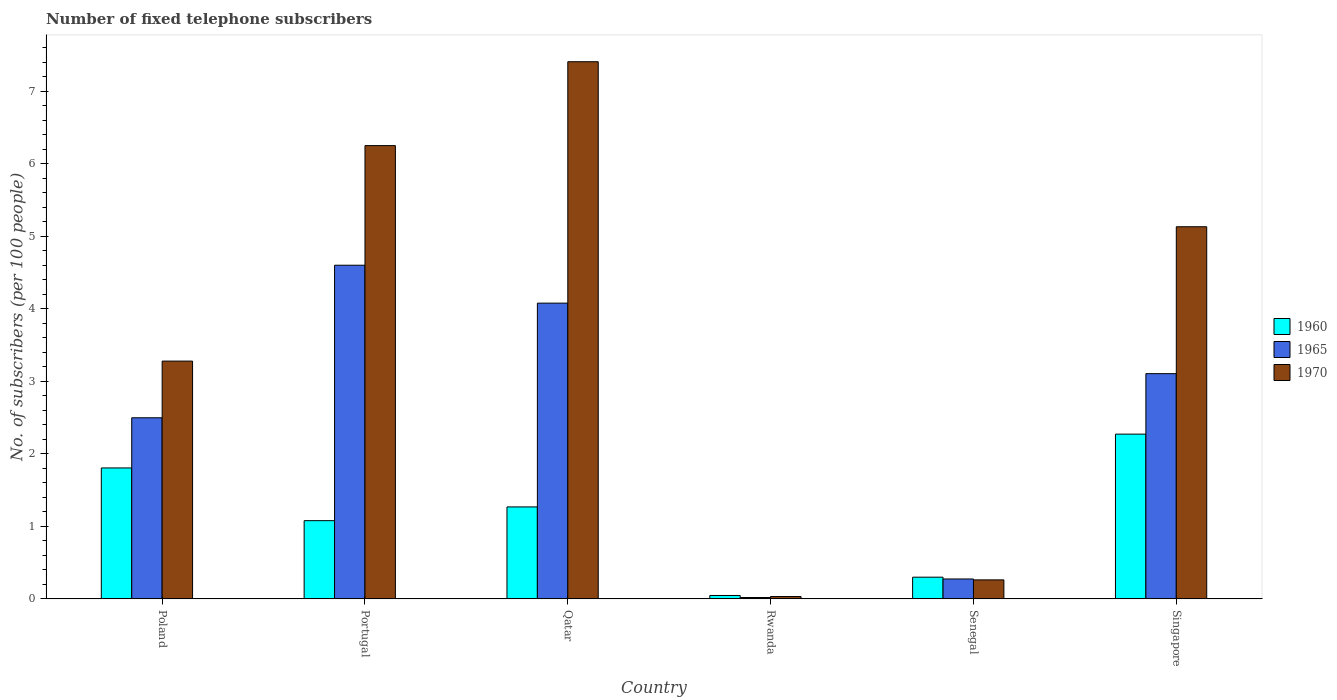What is the label of the 3rd group of bars from the left?
Provide a short and direct response. Qatar. What is the number of fixed telephone subscribers in 1970 in Senegal?
Offer a very short reply. 0.26. Across all countries, what is the maximum number of fixed telephone subscribers in 1965?
Your response must be concise. 4.6. Across all countries, what is the minimum number of fixed telephone subscribers in 1965?
Provide a short and direct response. 0.02. In which country was the number of fixed telephone subscribers in 1970 maximum?
Ensure brevity in your answer.  Qatar. In which country was the number of fixed telephone subscribers in 1965 minimum?
Provide a succinct answer. Rwanda. What is the total number of fixed telephone subscribers in 1970 in the graph?
Keep it short and to the point. 22.36. What is the difference between the number of fixed telephone subscribers in 1970 in Portugal and that in Singapore?
Make the answer very short. 1.12. What is the difference between the number of fixed telephone subscribers in 1970 in Senegal and the number of fixed telephone subscribers in 1960 in Rwanda?
Your answer should be very brief. 0.22. What is the average number of fixed telephone subscribers in 1970 per country?
Offer a terse response. 3.73. What is the difference between the number of fixed telephone subscribers of/in 1965 and number of fixed telephone subscribers of/in 1960 in Qatar?
Your response must be concise. 2.81. What is the ratio of the number of fixed telephone subscribers in 1960 in Qatar to that in Senegal?
Provide a short and direct response. 4.24. Is the number of fixed telephone subscribers in 1970 in Portugal less than that in Rwanda?
Provide a short and direct response. No. Is the difference between the number of fixed telephone subscribers in 1965 in Poland and Rwanda greater than the difference between the number of fixed telephone subscribers in 1960 in Poland and Rwanda?
Give a very brief answer. Yes. What is the difference between the highest and the second highest number of fixed telephone subscribers in 1965?
Offer a very short reply. -1.5. What is the difference between the highest and the lowest number of fixed telephone subscribers in 1970?
Your answer should be very brief. 7.38. How many bars are there?
Keep it short and to the point. 18. How many countries are there in the graph?
Offer a very short reply. 6. Are the values on the major ticks of Y-axis written in scientific E-notation?
Give a very brief answer. No. Does the graph contain grids?
Give a very brief answer. No. How many legend labels are there?
Your response must be concise. 3. What is the title of the graph?
Offer a terse response. Number of fixed telephone subscribers. What is the label or title of the Y-axis?
Offer a very short reply. No. of subscribers (per 100 people). What is the No. of subscribers (per 100 people) in 1960 in Poland?
Your answer should be compact. 1.81. What is the No. of subscribers (per 100 people) in 1965 in Poland?
Provide a succinct answer. 2.5. What is the No. of subscribers (per 100 people) of 1970 in Poland?
Offer a terse response. 3.28. What is the No. of subscribers (per 100 people) in 1960 in Portugal?
Your response must be concise. 1.08. What is the No. of subscribers (per 100 people) of 1965 in Portugal?
Your answer should be very brief. 4.6. What is the No. of subscribers (per 100 people) of 1970 in Portugal?
Give a very brief answer. 6.25. What is the No. of subscribers (per 100 people) in 1960 in Qatar?
Offer a terse response. 1.27. What is the No. of subscribers (per 100 people) of 1965 in Qatar?
Provide a short and direct response. 4.08. What is the No. of subscribers (per 100 people) in 1970 in Qatar?
Offer a very short reply. 7.41. What is the No. of subscribers (per 100 people) of 1960 in Rwanda?
Your answer should be very brief. 0.05. What is the No. of subscribers (per 100 people) in 1965 in Rwanda?
Keep it short and to the point. 0.02. What is the No. of subscribers (per 100 people) of 1970 in Rwanda?
Provide a short and direct response. 0.03. What is the No. of subscribers (per 100 people) of 1960 in Senegal?
Your answer should be very brief. 0.3. What is the No. of subscribers (per 100 people) in 1965 in Senegal?
Provide a short and direct response. 0.27. What is the No. of subscribers (per 100 people) in 1970 in Senegal?
Offer a very short reply. 0.26. What is the No. of subscribers (per 100 people) in 1960 in Singapore?
Your answer should be very brief. 2.27. What is the No. of subscribers (per 100 people) of 1965 in Singapore?
Your response must be concise. 3.11. What is the No. of subscribers (per 100 people) in 1970 in Singapore?
Your response must be concise. 5.13. Across all countries, what is the maximum No. of subscribers (per 100 people) of 1960?
Your response must be concise. 2.27. Across all countries, what is the maximum No. of subscribers (per 100 people) of 1965?
Offer a terse response. 4.6. Across all countries, what is the maximum No. of subscribers (per 100 people) of 1970?
Provide a succinct answer. 7.41. Across all countries, what is the minimum No. of subscribers (per 100 people) in 1960?
Ensure brevity in your answer.  0.05. Across all countries, what is the minimum No. of subscribers (per 100 people) in 1965?
Provide a short and direct response. 0.02. Across all countries, what is the minimum No. of subscribers (per 100 people) of 1970?
Provide a succinct answer. 0.03. What is the total No. of subscribers (per 100 people) in 1960 in the graph?
Keep it short and to the point. 6.77. What is the total No. of subscribers (per 100 people) of 1965 in the graph?
Your answer should be compact. 14.58. What is the total No. of subscribers (per 100 people) of 1970 in the graph?
Make the answer very short. 22.36. What is the difference between the No. of subscribers (per 100 people) of 1960 in Poland and that in Portugal?
Provide a succinct answer. 0.73. What is the difference between the No. of subscribers (per 100 people) in 1965 in Poland and that in Portugal?
Offer a very short reply. -2.1. What is the difference between the No. of subscribers (per 100 people) in 1970 in Poland and that in Portugal?
Give a very brief answer. -2.97. What is the difference between the No. of subscribers (per 100 people) in 1960 in Poland and that in Qatar?
Your response must be concise. 0.54. What is the difference between the No. of subscribers (per 100 people) of 1965 in Poland and that in Qatar?
Offer a very short reply. -1.58. What is the difference between the No. of subscribers (per 100 people) in 1970 in Poland and that in Qatar?
Your answer should be very brief. -4.13. What is the difference between the No. of subscribers (per 100 people) of 1960 in Poland and that in Rwanda?
Offer a very short reply. 1.76. What is the difference between the No. of subscribers (per 100 people) of 1965 in Poland and that in Rwanda?
Provide a short and direct response. 2.48. What is the difference between the No. of subscribers (per 100 people) of 1970 in Poland and that in Rwanda?
Keep it short and to the point. 3.25. What is the difference between the No. of subscribers (per 100 people) in 1960 in Poland and that in Senegal?
Offer a terse response. 1.51. What is the difference between the No. of subscribers (per 100 people) of 1965 in Poland and that in Senegal?
Make the answer very short. 2.22. What is the difference between the No. of subscribers (per 100 people) of 1970 in Poland and that in Senegal?
Provide a succinct answer. 3.02. What is the difference between the No. of subscribers (per 100 people) in 1960 in Poland and that in Singapore?
Keep it short and to the point. -0.47. What is the difference between the No. of subscribers (per 100 people) in 1965 in Poland and that in Singapore?
Offer a very short reply. -0.61. What is the difference between the No. of subscribers (per 100 people) in 1970 in Poland and that in Singapore?
Provide a short and direct response. -1.85. What is the difference between the No. of subscribers (per 100 people) in 1960 in Portugal and that in Qatar?
Make the answer very short. -0.19. What is the difference between the No. of subscribers (per 100 people) of 1965 in Portugal and that in Qatar?
Give a very brief answer. 0.52. What is the difference between the No. of subscribers (per 100 people) in 1970 in Portugal and that in Qatar?
Your answer should be very brief. -1.16. What is the difference between the No. of subscribers (per 100 people) of 1960 in Portugal and that in Rwanda?
Offer a terse response. 1.03. What is the difference between the No. of subscribers (per 100 people) of 1965 in Portugal and that in Rwanda?
Provide a succinct answer. 4.58. What is the difference between the No. of subscribers (per 100 people) in 1970 in Portugal and that in Rwanda?
Provide a succinct answer. 6.22. What is the difference between the No. of subscribers (per 100 people) of 1960 in Portugal and that in Senegal?
Your response must be concise. 0.78. What is the difference between the No. of subscribers (per 100 people) of 1965 in Portugal and that in Senegal?
Ensure brevity in your answer.  4.33. What is the difference between the No. of subscribers (per 100 people) in 1970 in Portugal and that in Senegal?
Your answer should be compact. 5.99. What is the difference between the No. of subscribers (per 100 people) of 1960 in Portugal and that in Singapore?
Offer a terse response. -1.19. What is the difference between the No. of subscribers (per 100 people) of 1965 in Portugal and that in Singapore?
Give a very brief answer. 1.5. What is the difference between the No. of subscribers (per 100 people) of 1970 in Portugal and that in Singapore?
Offer a very short reply. 1.12. What is the difference between the No. of subscribers (per 100 people) of 1960 in Qatar and that in Rwanda?
Offer a terse response. 1.22. What is the difference between the No. of subscribers (per 100 people) in 1965 in Qatar and that in Rwanda?
Keep it short and to the point. 4.06. What is the difference between the No. of subscribers (per 100 people) of 1970 in Qatar and that in Rwanda?
Give a very brief answer. 7.38. What is the difference between the No. of subscribers (per 100 people) in 1960 in Qatar and that in Senegal?
Offer a terse response. 0.97. What is the difference between the No. of subscribers (per 100 people) in 1965 in Qatar and that in Senegal?
Make the answer very short. 3.8. What is the difference between the No. of subscribers (per 100 people) of 1970 in Qatar and that in Senegal?
Keep it short and to the point. 7.15. What is the difference between the No. of subscribers (per 100 people) of 1960 in Qatar and that in Singapore?
Keep it short and to the point. -1. What is the difference between the No. of subscribers (per 100 people) in 1965 in Qatar and that in Singapore?
Provide a short and direct response. 0.97. What is the difference between the No. of subscribers (per 100 people) in 1970 in Qatar and that in Singapore?
Provide a short and direct response. 2.28. What is the difference between the No. of subscribers (per 100 people) of 1960 in Rwanda and that in Senegal?
Offer a very short reply. -0.25. What is the difference between the No. of subscribers (per 100 people) in 1965 in Rwanda and that in Senegal?
Give a very brief answer. -0.26. What is the difference between the No. of subscribers (per 100 people) in 1970 in Rwanda and that in Senegal?
Your answer should be compact. -0.23. What is the difference between the No. of subscribers (per 100 people) in 1960 in Rwanda and that in Singapore?
Offer a terse response. -2.23. What is the difference between the No. of subscribers (per 100 people) in 1965 in Rwanda and that in Singapore?
Your answer should be compact. -3.09. What is the difference between the No. of subscribers (per 100 people) in 1970 in Rwanda and that in Singapore?
Your answer should be compact. -5.1. What is the difference between the No. of subscribers (per 100 people) in 1960 in Senegal and that in Singapore?
Ensure brevity in your answer.  -1.97. What is the difference between the No. of subscribers (per 100 people) in 1965 in Senegal and that in Singapore?
Offer a terse response. -2.83. What is the difference between the No. of subscribers (per 100 people) of 1970 in Senegal and that in Singapore?
Your answer should be very brief. -4.87. What is the difference between the No. of subscribers (per 100 people) in 1960 in Poland and the No. of subscribers (per 100 people) in 1965 in Portugal?
Your answer should be very brief. -2.8. What is the difference between the No. of subscribers (per 100 people) of 1960 in Poland and the No. of subscribers (per 100 people) of 1970 in Portugal?
Provide a succinct answer. -4.45. What is the difference between the No. of subscribers (per 100 people) of 1965 in Poland and the No. of subscribers (per 100 people) of 1970 in Portugal?
Ensure brevity in your answer.  -3.75. What is the difference between the No. of subscribers (per 100 people) in 1960 in Poland and the No. of subscribers (per 100 people) in 1965 in Qatar?
Provide a succinct answer. -2.27. What is the difference between the No. of subscribers (per 100 people) in 1960 in Poland and the No. of subscribers (per 100 people) in 1970 in Qatar?
Your response must be concise. -5.6. What is the difference between the No. of subscribers (per 100 people) of 1965 in Poland and the No. of subscribers (per 100 people) of 1970 in Qatar?
Keep it short and to the point. -4.91. What is the difference between the No. of subscribers (per 100 people) in 1960 in Poland and the No. of subscribers (per 100 people) in 1965 in Rwanda?
Keep it short and to the point. 1.79. What is the difference between the No. of subscribers (per 100 people) of 1960 in Poland and the No. of subscribers (per 100 people) of 1970 in Rwanda?
Make the answer very short. 1.77. What is the difference between the No. of subscribers (per 100 people) of 1965 in Poland and the No. of subscribers (per 100 people) of 1970 in Rwanda?
Offer a terse response. 2.47. What is the difference between the No. of subscribers (per 100 people) in 1960 in Poland and the No. of subscribers (per 100 people) in 1965 in Senegal?
Give a very brief answer. 1.53. What is the difference between the No. of subscribers (per 100 people) in 1960 in Poland and the No. of subscribers (per 100 people) in 1970 in Senegal?
Provide a succinct answer. 1.54. What is the difference between the No. of subscribers (per 100 people) of 1965 in Poland and the No. of subscribers (per 100 people) of 1970 in Senegal?
Ensure brevity in your answer.  2.24. What is the difference between the No. of subscribers (per 100 people) in 1960 in Poland and the No. of subscribers (per 100 people) in 1965 in Singapore?
Ensure brevity in your answer.  -1.3. What is the difference between the No. of subscribers (per 100 people) in 1960 in Poland and the No. of subscribers (per 100 people) in 1970 in Singapore?
Ensure brevity in your answer.  -3.33. What is the difference between the No. of subscribers (per 100 people) in 1965 in Poland and the No. of subscribers (per 100 people) in 1970 in Singapore?
Keep it short and to the point. -2.63. What is the difference between the No. of subscribers (per 100 people) of 1960 in Portugal and the No. of subscribers (per 100 people) of 1965 in Qatar?
Offer a terse response. -3. What is the difference between the No. of subscribers (per 100 people) of 1960 in Portugal and the No. of subscribers (per 100 people) of 1970 in Qatar?
Your answer should be compact. -6.33. What is the difference between the No. of subscribers (per 100 people) of 1965 in Portugal and the No. of subscribers (per 100 people) of 1970 in Qatar?
Give a very brief answer. -2.81. What is the difference between the No. of subscribers (per 100 people) of 1960 in Portugal and the No. of subscribers (per 100 people) of 1965 in Rwanda?
Ensure brevity in your answer.  1.06. What is the difference between the No. of subscribers (per 100 people) in 1960 in Portugal and the No. of subscribers (per 100 people) in 1970 in Rwanda?
Provide a short and direct response. 1.05. What is the difference between the No. of subscribers (per 100 people) of 1965 in Portugal and the No. of subscribers (per 100 people) of 1970 in Rwanda?
Keep it short and to the point. 4.57. What is the difference between the No. of subscribers (per 100 people) in 1960 in Portugal and the No. of subscribers (per 100 people) in 1965 in Senegal?
Provide a short and direct response. 0.8. What is the difference between the No. of subscribers (per 100 people) in 1960 in Portugal and the No. of subscribers (per 100 people) in 1970 in Senegal?
Make the answer very short. 0.82. What is the difference between the No. of subscribers (per 100 people) of 1965 in Portugal and the No. of subscribers (per 100 people) of 1970 in Senegal?
Ensure brevity in your answer.  4.34. What is the difference between the No. of subscribers (per 100 people) of 1960 in Portugal and the No. of subscribers (per 100 people) of 1965 in Singapore?
Provide a succinct answer. -2.03. What is the difference between the No. of subscribers (per 100 people) in 1960 in Portugal and the No. of subscribers (per 100 people) in 1970 in Singapore?
Give a very brief answer. -4.05. What is the difference between the No. of subscribers (per 100 people) of 1965 in Portugal and the No. of subscribers (per 100 people) of 1970 in Singapore?
Your answer should be very brief. -0.53. What is the difference between the No. of subscribers (per 100 people) of 1960 in Qatar and the No. of subscribers (per 100 people) of 1965 in Rwanda?
Ensure brevity in your answer.  1.25. What is the difference between the No. of subscribers (per 100 people) in 1960 in Qatar and the No. of subscribers (per 100 people) in 1970 in Rwanda?
Provide a short and direct response. 1.24. What is the difference between the No. of subscribers (per 100 people) of 1965 in Qatar and the No. of subscribers (per 100 people) of 1970 in Rwanda?
Offer a terse response. 4.05. What is the difference between the No. of subscribers (per 100 people) of 1960 in Qatar and the No. of subscribers (per 100 people) of 1965 in Senegal?
Keep it short and to the point. 0.99. What is the difference between the No. of subscribers (per 100 people) of 1960 in Qatar and the No. of subscribers (per 100 people) of 1970 in Senegal?
Your answer should be compact. 1.01. What is the difference between the No. of subscribers (per 100 people) in 1965 in Qatar and the No. of subscribers (per 100 people) in 1970 in Senegal?
Make the answer very short. 3.82. What is the difference between the No. of subscribers (per 100 people) of 1960 in Qatar and the No. of subscribers (per 100 people) of 1965 in Singapore?
Make the answer very short. -1.84. What is the difference between the No. of subscribers (per 100 people) in 1960 in Qatar and the No. of subscribers (per 100 people) in 1970 in Singapore?
Make the answer very short. -3.86. What is the difference between the No. of subscribers (per 100 people) in 1965 in Qatar and the No. of subscribers (per 100 people) in 1970 in Singapore?
Your answer should be compact. -1.05. What is the difference between the No. of subscribers (per 100 people) in 1960 in Rwanda and the No. of subscribers (per 100 people) in 1965 in Senegal?
Provide a succinct answer. -0.23. What is the difference between the No. of subscribers (per 100 people) of 1960 in Rwanda and the No. of subscribers (per 100 people) of 1970 in Senegal?
Ensure brevity in your answer.  -0.22. What is the difference between the No. of subscribers (per 100 people) in 1965 in Rwanda and the No. of subscribers (per 100 people) in 1970 in Senegal?
Provide a succinct answer. -0.24. What is the difference between the No. of subscribers (per 100 people) in 1960 in Rwanda and the No. of subscribers (per 100 people) in 1965 in Singapore?
Ensure brevity in your answer.  -3.06. What is the difference between the No. of subscribers (per 100 people) of 1960 in Rwanda and the No. of subscribers (per 100 people) of 1970 in Singapore?
Your answer should be very brief. -5.09. What is the difference between the No. of subscribers (per 100 people) in 1965 in Rwanda and the No. of subscribers (per 100 people) in 1970 in Singapore?
Provide a short and direct response. -5.11. What is the difference between the No. of subscribers (per 100 people) in 1960 in Senegal and the No. of subscribers (per 100 people) in 1965 in Singapore?
Ensure brevity in your answer.  -2.81. What is the difference between the No. of subscribers (per 100 people) of 1960 in Senegal and the No. of subscribers (per 100 people) of 1970 in Singapore?
Keep it short and to the point. -4.83. What is the difference between the No. of subscribers (per 100 people) in 1965 in Senegal and the No. of subscribers (per 100 people) in 1970 in Singapore?
Your answer should be very brief. -4.86. What is the average No. of subscribers (per 100 people) in 1960 per country?
Keep it short and to the point. 1.13. What is the average No. of subscribers (per 100 people) in 1965 per country?
Make the answer very short. 2.43. What is the average No. of subscribers (per 100 people) of 1970 per country?
Make the answer very short. 3.73. What is the difference between the No. of subscribers (per 100 people) in 1960 and No. of subscribers (per 100 people) in 1965 in Poland?
Offer a very short reply. -0.69. What is the difference between the No. of subscribers (per 100 people) in 1960 and No. of subscribers (per 100 people) in 1970 in Poland?
Your answer should be compact. -1.47. What is the difference between the No. of subscribers (per 100 people) of 1965 and No. of subscribers (per 100 people) of 1970 in Poland?
Keep it short and to the point. -0.78. What is the difference between the No. of subscribers (per 100 people) in 1960 and No. of subscribers (per 100 people) in 1965 in Portugal?
Your answer should be compact. -3.52. What is the difference between the No. of subscribers (per 100 people) of 1960 and No. of subscribers (per 100 people) of 1970 in Portugal?
Provide a short and direct response. -5.17. What is the difference between the No. of subscribers (per 100 people) in 1965 and No. of subscribers (per 100 people) in 1970 in Portugal?
Keep it short and to the point. -1.65. What is the difference between the No. of subscribers (per 100 people) of 1960 and No. of subscribers (per 100 people) of 1965 in Qatar?
Your answer should be very brief. -2.81. What is the difference between the No. of subscribers (per 100 people) in 1960 and No. of subscribers (per 100 people) in 1970 in Qatar?
Give a very brief answer. -6.14. What is the difference between the No. of subscribers (per 100 people) of 1965 and No. of subscribers (per 100 people) of 1970 in Qatar?
Your answer should be very brief. -3.33. What is the difference between the No. of subscribers (per 100 people) in 1960 and No. of subscribers (per 100 people) in 1965 in Rwanda?
Give a very brief answer. 0.03. What is the difference between the No. of subscribers (per 100 people) in 1960 and No. of subscribers (per 100 people) in 1970 in Rwanda?
Ensure brevity in your answer.  0.01. What is the difference between the No. of subscribers (per 100 people) in 1965 and No. of subscribers (per 100 people) in 1970 in Rwanda?
Provide a succinct answer. -0.01. What is the difference between the No. of subscribers (per 100 people) in 1960 and No. of subscribers (per 100 people) in 1965 in Senegal?
Offer a terse response. 0.02. What is the difference between the No. of subscribers (per 100 people) in 1960 and No. of subscribers (per 100 people) in 1970 in Senegal?
Provide a succinct answer. 0.04. What is the difference between the No. of subscribers (per 100 people) in 1965 and No. of subscribers (per 100 people) in 1970 in Senegal?
Make the answer very short. 0.01. What is the difference between the No. of subscribers (per 100 people) of 1960 and No. of subscribers (per 100 people) of 1965 in Singapore?
Provide a succinct answer. -0.83. What is the difference between the No. of subscribers (per 100 people) in 1960 and No. of subscribers (per 100 people) in 1970 in Singapore?
Offer a terse response. -2.86. What is the difference between the No. of subscribers (per 100 people) of 1965 and No. of subscribers (per 100 people) of 1970 in Singapore?
Give a very brief answer. -2.03. What is the ratio of the No. of subscribers (per 100 people) of 1960 in Poland to that in Portugal?
Your response must be concise. 1.67. What is the ratio of the No. of subscribers (per 100 people) of 1965 in Poland to that in Portugal?
Your answer should be compact. 0.54. What is the ratio of the No. of subscribers (per 100 people) in 1970 in Poland to that in Portugal?
Your answer should be very brief. 0.52. What is the ratio of the No. of subscribers (per 100 people) in 1960 in Poland to that in Qatar?
Offer a terse response. 1.42. What is the ratio of the No. of subscribers (per 100 people) of 1965 in Poland to that in Qatar?
Provide a succinct answer. 0.61. What is the ratio of the No. of subscribers (per 100 people) of 1970 in Poland to that in Qatar?
Provide a succinct answer. 0.44. What is the ratio of the No. of subscribers (per 100 people) in 1960 in Poland to that in Rwanda?
Your answer should be compact. 38.77. What is the ratio of the No. of subscribers (per 100 people) of 1965 in Poland to that in Rwanda?
Offer a very short reply. 134.57. What is the ratio of the No. of subscribers (per 100 people) of 1970 in Poland to that in Rwanda?
Your answer should be compact. 102.59. What is the ratio of the No. of subscribers (per 100 people) in 1960 in Poland to that in Senegal?
Your answer should be very brief. 6.04. What is the ratio of the No. of subscribers (per 100 people) in 1965 in Poland to that in Senegal?
Ensure brevity in your answer.  9.11. What is the ratio of the No. of subscribers (per 100 people) in 1970 in Poland to that in Senegal?
Offer a terse response. 12.53. What is the ratio of the No. of subscribers (per 100 people) in 1960 in Poland to that in Singapore?
Offer a very short reply. 0.79. What is the ratio of the No. of subscribers (per 100 people) in 1965 in Poland to that in Singapore?
Offer a very short reply. 0.8. What is the ratio of the No. of subscribers (per 100 people) of 1970 in Poland to that in Singapore?
Your answer should be compact. 0.64. What is the ratio of the No. of subscribers (per 100 people) of 1960 in Portugal to that in Qatar?
Offer a terse response. 0.85. What is the ratio of the No. of subscribers (per 100 people) in 1965 in Portugal to that in Qatar?
Your answer should be compact. 1.13. What is the ratio of the No. of subscribers (per 100 people) in 1970 in Portugal to that in Qatar?
Your answer should be very brief. 0.84. What is the ratio of the No. of subscribers (per 100 people) of 1960 in Portugal to that in Rwanda?
Your response must be concise. 23.15. What is the ratio of the No. of subscribers (per 100 people) of 1965 in Portugal to that in Rwanda?
Give a very brief answer. 247.93. What is the ratio of the No. of subscribers (per 100 people) of 1970 in Portugal to that in Rwanda?
Ensure brevity in your answer.  195.59. What is the ratio of the No. of subscribers (per 100 people) in 1960 in Portugal to that in Senegal?
Your response must be concise. 3.61. What is the ratio of the No. of subscribers (per 100 people) of 1965 in Portugal to that in Senegal?
Your answer should be compact. 16.79. What is the ratio of the No. of subscribers (per 100 people) of 1970 in Portugal to that in Senegal?
Offer a terse response. 23.89. What is the ratio of the No. of subscribers (per 100 people) in 1960 in Portugal to that in Singapore?
Your response must be concise. 0.47. What is the ratio of the No. of subscribers (per 100 people) in 1965 in Portugal to that in Singapore?
Your answer should be compact. 1.48. What is the ratio of the No. of subscribers (per 100 people) in 1970 in Portugal to that in Singapore?
Your answer should be compact. 1.22. What is the ratio of the No. of subscribers (per 100 people) of 1960 in Qatar to that in Rwanda?
Keep it short and to the point. 27.23. What is the ratio of the No. of subscribers (per 100 people) of 1965 in Qatar to that in Rwanda?
Provide a short and direct response. 219.77. What is the ratio of the No. of subscribers (per 100 people) in 1970 in Qatar to that in Rwanda?
Ensure brevity in your answer.  231.78. What is the ratio of the No. of subscribers (per 100 people) of 1960 in Qatar to that in Senegal?
Provide a succinct answer. 4.24. What is the ratio of the No. of subscribers (per 100 people) of 1965 in Qatar to that in Senegal?
Offer a terse response. 14.88. What is the ratio of the No. of subscribers (per 100 people) in 1970 in Qatar to that in Senegal?
Provide a succinct answer. 28.31. What is the ratio of the No. of subscribers (per 100 people) of 1960 in Qatar to that in Singapore?
Offer a terse response. 0.56. What is the ratio of the No. of subscribers (per 100 people) in 1965 in Qatar to that in Singapore?
Your response must be concise. 1.31. What is the ratio of the No. of subscribers (per 100 people) in 1970 in Qatar to that in Singapore?
Your response must be concise. 1.44. What is the ratio of the No. of subscribers (per 100 people) of 1960 in Rwanda to that in Senegal?
Your response must be concise. 0.16. What is the ratio of the No. of subscribers (per 100 people) in 1965 in Rwanda to that in Senegal?
Ensure brevity in your answer.  0.07. What is the ratio of the No. of subscribers (per 100 people) in 1970 in Rwanda to that in Senegal?
Keep it short and to the point. 0.12. What is the ratio of the No. of subscribers (per 100 people) in 1960 in Rwanda to that in Singapore?
Offer a terse response. 0.02. What is the ratio of the No. of subscribers (per 100 people) of 1965 in Rwanda to that in Singapore?
Provide a short and direct response. 0.01. What is the ratio of the No. of subscribers (per 100 people) in 1970 in Rwanda to that in Singapore?
Your answer should be compact. 0.01. What is the ratio of the No. of subscribers (per 100 people) of 1960 in Senegal to that in Singapore?
Make the answer very short. 0.13. What is the ratio of the No. of subscribers (per 100 people) of 1965 in Senegal to that in Singapore?
Give a very brief answer. 0.09. What is the ratio of the No. of subscribers (per 100 people) in 1970 in Senegal to that in Singapore?
Ensure brevity in your answer.  0.05. What is the difference between the highest and the second highest No. of subscribers (per 100 people) in 1960?
Offer a very short reply. 0.47. What is the difference between the highest and the second highest No. of subscribers (per 100 people) in 1965?
Keep it short and to the point. 0.52. What is the difference between the highest and the second highest No. of subscribers (per 100 people) in 1970?
Provide a short and direct response. 1.16. What is the difference between the highest and the lowest No. of subscribers (per 100 people) of 1960?
Provide a succinct answer. 2.23. What is the difference between the highest and the lowest No. of subscribers (per 100 people) in 1965?
Offer a very short reply. 4.58. What is the difference between the highest and the lowest No. of subscribers (per 100 people) of 1970?
Make the answer very short. 7.38. 